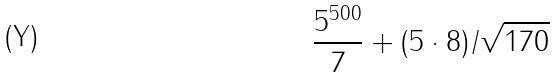Convert formula to latex. <formula><loc_0><loc_0><loc_500><loc_500>\frac { 5 ^ { 5 0 0 } } { 7 } + ( 5 \cdot 8 ) / \sqrt { 1 7 0 }</formula> 